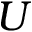<formula> <loc_0><loc_0><loc_500><loc_500>U</formula> 